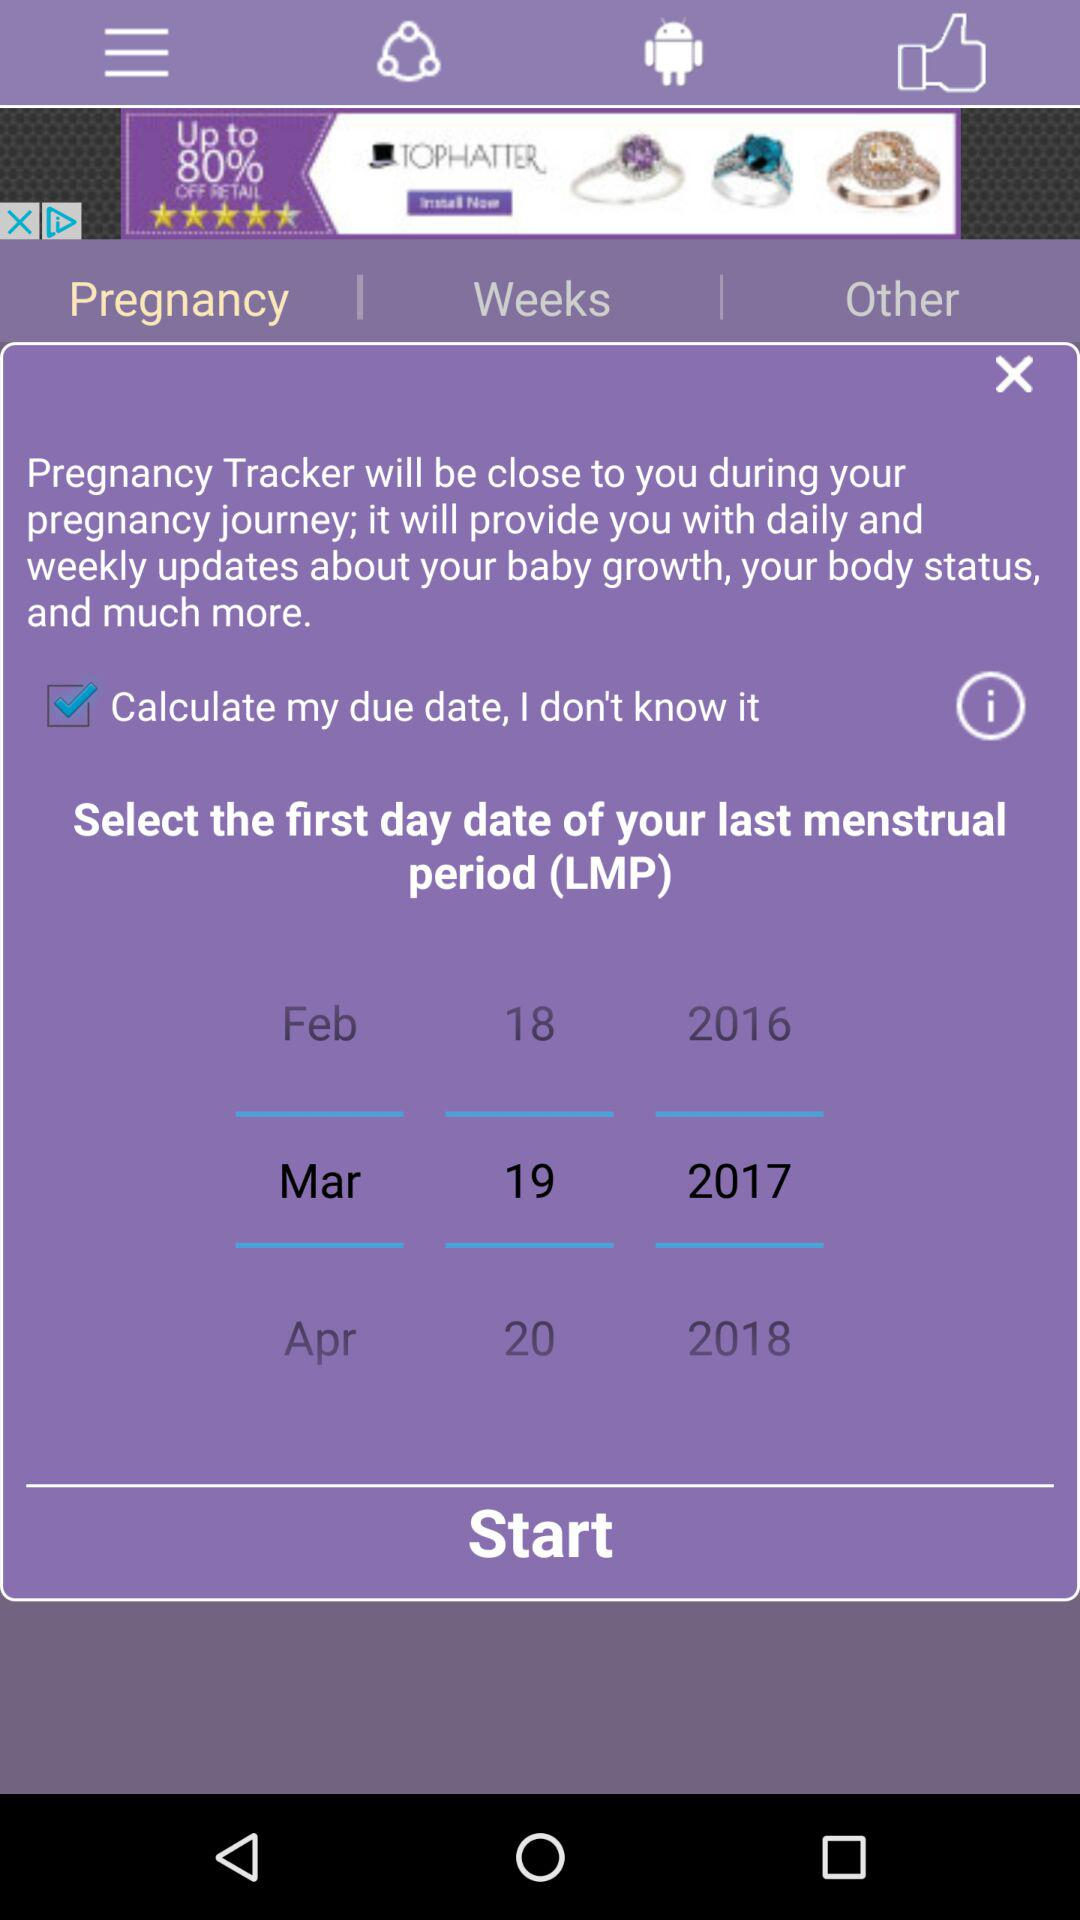Which tab has been selected? The selected tabs are "Android" and "Pregnancy". 